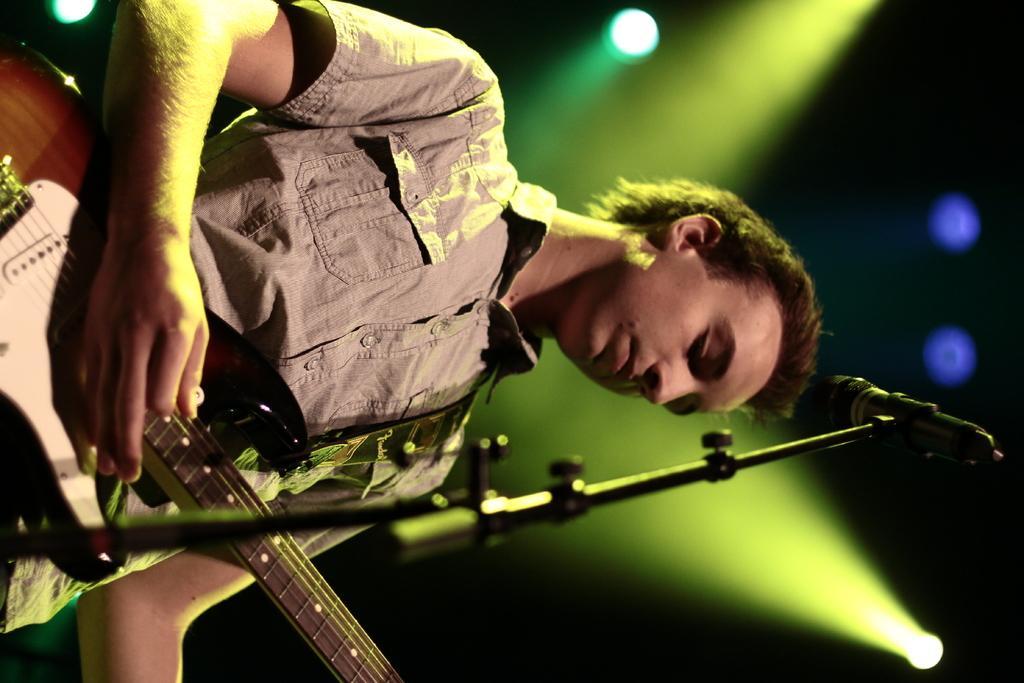Describe this image in one or two sentences. In this image we can see a man playing the guitar and standing in front of the mike stand. In the background we can see the lights. 